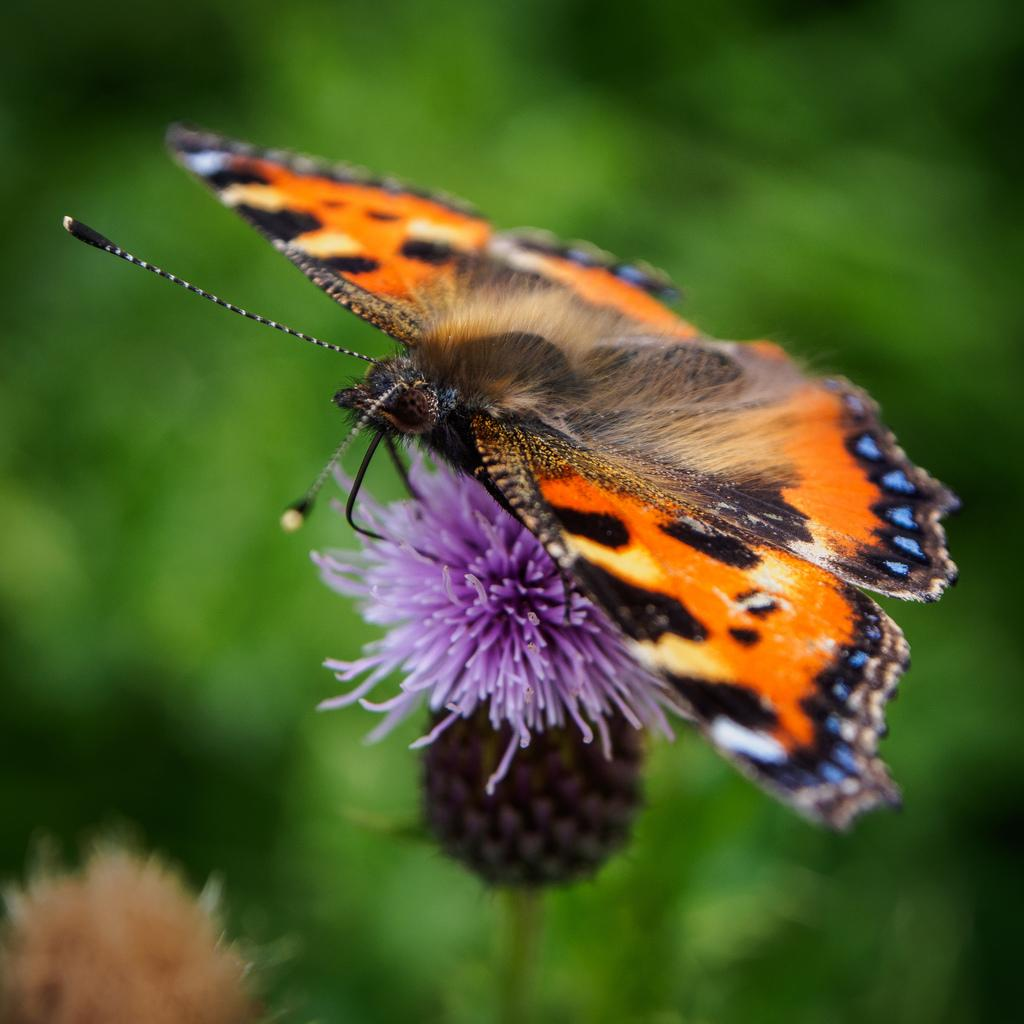What is the main subject of the image? There is a butterfly in the image. Where is the butterfly located in the image? The butterfly is on a flower. Can you describe the flower in the image? There is a flower in the bottom left corner of the image. How would you describe the overall appearance of the image? The background of the image is blurry. What type of vacation is the butterfly planning to take in the image? There is no indication in the image that the butterfly is planning a vacation, as butterflies do not plan vacations. 